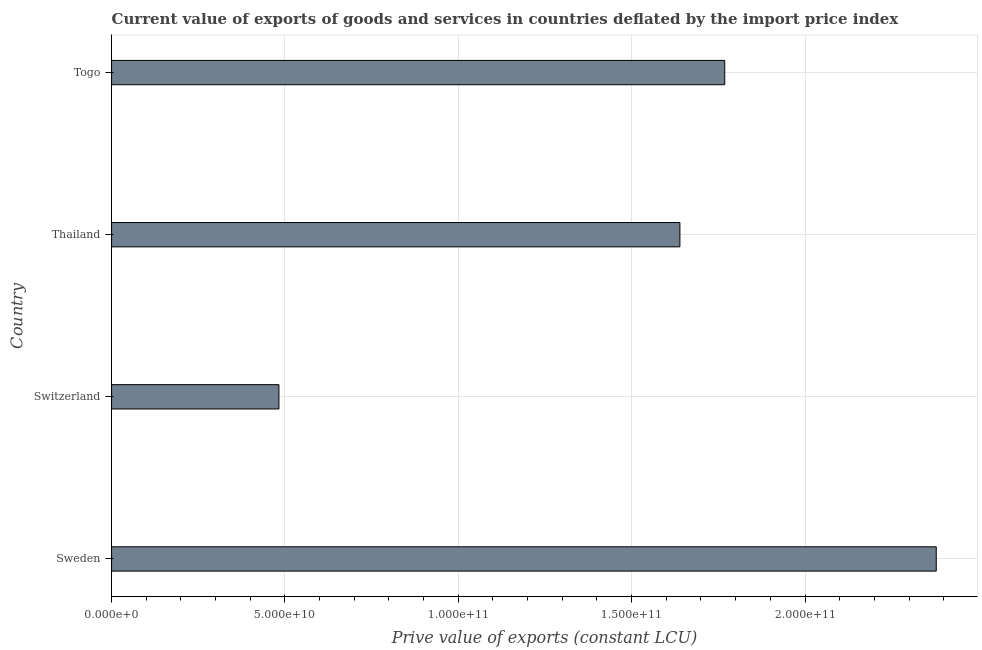Does the graph contain any zero values?
Your response must be concise. No. What is the title of the graph?
Your answer should be very brief. Current value of exports of goods and services in countries deflated by the import price index. What is the label or title of the X-axis?
Keep it short and to the point. Prive value of exports (constant LCU). What is the price value of exports in Thailand?
Your answer should be very brief. 1.64e+11. Across all countries, what is the maximum price value of exports?
Your response must be concise. 2.38e+11. Across all countries, what is the minimum price value of exports?
Provide a short and direct response. 4.83e+1. In which country was the price value of exports minimum?
Ensure brevity in your answer.  Switzerland. What is the sum of the price value of exports?
Offer a very short reply. 6.27e+11. What is the difference between the price value of exports in Sweden and Thailand?
Give a very brief answer. 7.39e+1. What is the average price value of exports per country?
Give a very brief answer. 1.57e+11. What is the median price value of exports?
Provide a succinct answer. 1.70e+11. In how many countries, is the price value of exports greater than 100000000000 LCU?
Give a very brief answer. 3. What is the ratio of the price value of exports in Sweden to that in Thailand?
Ensure brevity in your answer.  1.45. Is the price value of exports in Thailand less than that in Togo?
Keep it short and to the point. Yes. What is the difference between the highest and the second highest price value of exports?
Offer a terse response. 6.10e+1. Is the sum of the price value of exports in Sweden and Togo greater than the maximum price value of exports across all countries?
Ensure brevity in your answer.  Yes. What is the difference between the highest and the lowest price value of exports?
Give a very brief answer. 1.90e+11. How many bars are there?
Offer a terse response. 4. Are all the bars in the graph horizontal?
Offer a very short reply. Yes. What is the difference between two consecutive major ticks on the X-axis?
Keep it short and to the point. 5.00e+1. Are the values on the major ticks of X-axis written in scientific E-notation?
Ensure brevity in your answer.  Yes. What is the Prive value of exports (constant LCU) of Sweden?
Your response must be concise. 2.38e+11. What is the Prive value of exports (constant LCU) of Switzerland?
Offer a very short reply. 4.83e+1. What is the Prive value of exports (constant LCU) of Thailand?
Your answer should be compact. 1.64e+11. What is the Prive value of exports (constant LCU) of Togo?
Your response must be concise. 1.77e+11. What is the difference between the Prive value of exports (constant LCU) in Sweden and Switzerland?
Ensure brevity in your answer.  1.90e+11. What is the difference between the Prive value of exports (constant LCU) in Sweden and Thailand?
Ensure brevity in your answer.  7.39e+1. What is the difference between the Prive value of exports (constant LCU) in Sweden and Togo?
Keep it short and to the point. 6.10e+1. What is the difference between the Prive value of exports (constant LCU) in Switzerland and Thailand?
Your answer should be compact. -1.16e+11. What is the difference between the Prive value of exports (constant LCU) in Switzerland and Togo?
Give a very brief answer. -1.29e+11. What is the difference between the Prive value of exports (constant LCU) in Thailand and Togo?
Keep it short and to the point. -1.29e+1. What is the ratio of the Prive value of exports (constant LCU) in Sweden to that in Switzerland?
Ensure brevity in your answer.  4.93. What is the ratio of the Prive value of exports (constant LCU) in Sweden to that in Thailand?
Keep it short and to the point. 1.45. What is the ratio of the Prive value of exports (constant LCU) in Sweden to that in Togo?
Your response must be concise. 1.34. What is the ratio of the Prive value of exports (constant LCU) in Switzerland to that in Thailand?
Your answer should be compact. 0.29. What is the ratio of the Prive value of exports (constant LCU) in Switzerland to that in Togo?
Make the answer very short. 0.27. What is the ratio of the Prive value of exports (constant LCU) in Thailand to that in Togo?
Ensure brevity in your answer.  0.93. 